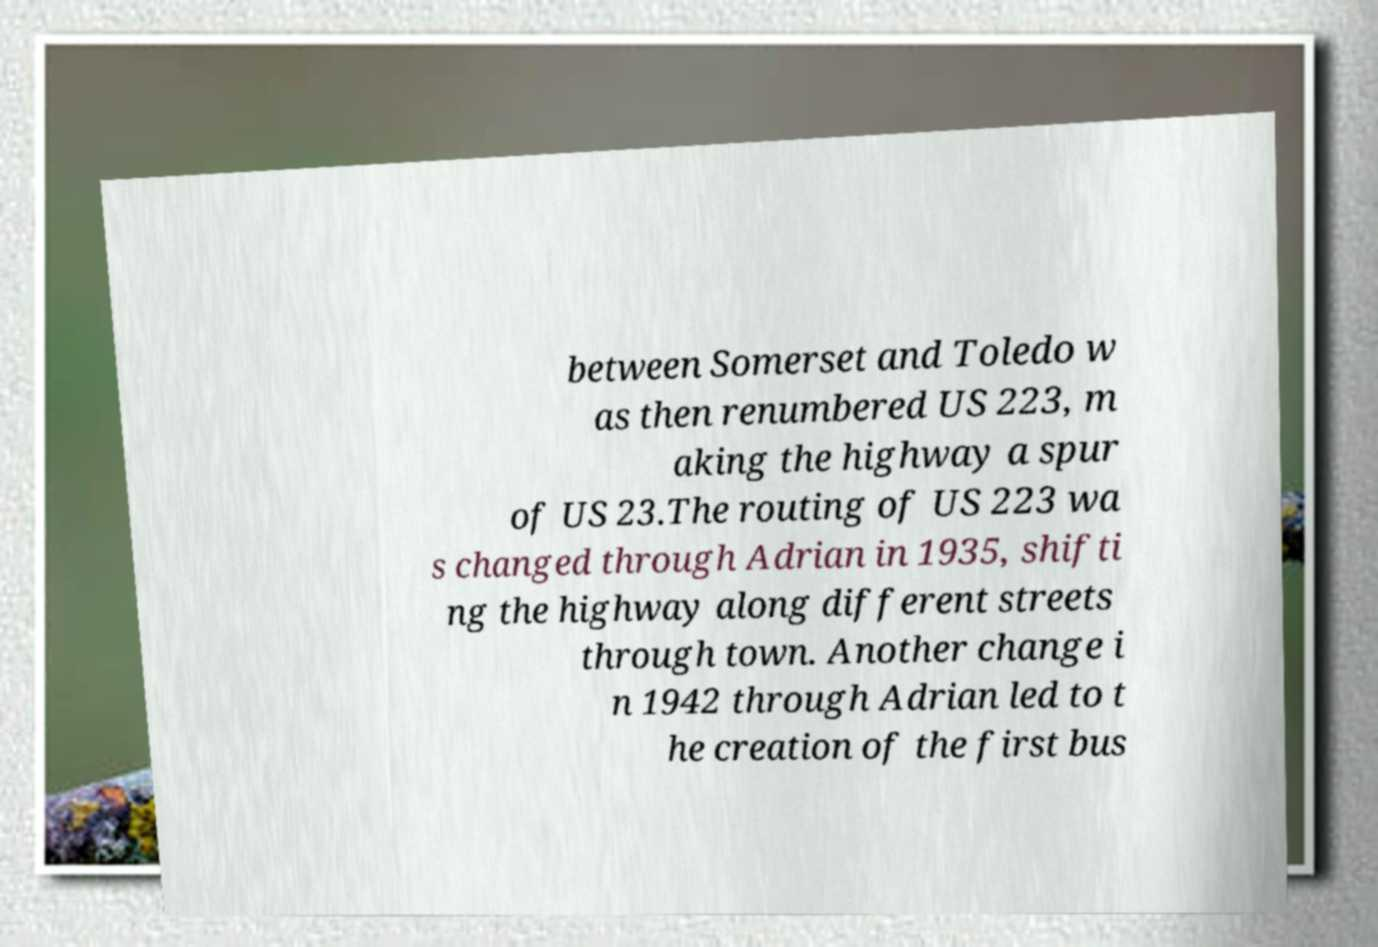Could you extract and type out the text from this image? between Somerset and Toledo w as then renumbered US 223, m aking the highway a spur of US 23.The routing of US 223 wa s changed through Adrian in 1935, shifti ng the highway along different streets through town. Another change i n 1942 through Adrian led to t he creation of the first bus 